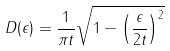Convert formula to latex. <formula><loc_0><loc_0><loc_500><loc_500>D ( \epsilon ) = \frac { 1 } { \pi t } \sqrt { 1 - \left ( \frac { \epsilon } { 2 t } \right ) ^ { 2 } }</formula> 